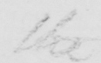What is written in this line of handwriting? the 